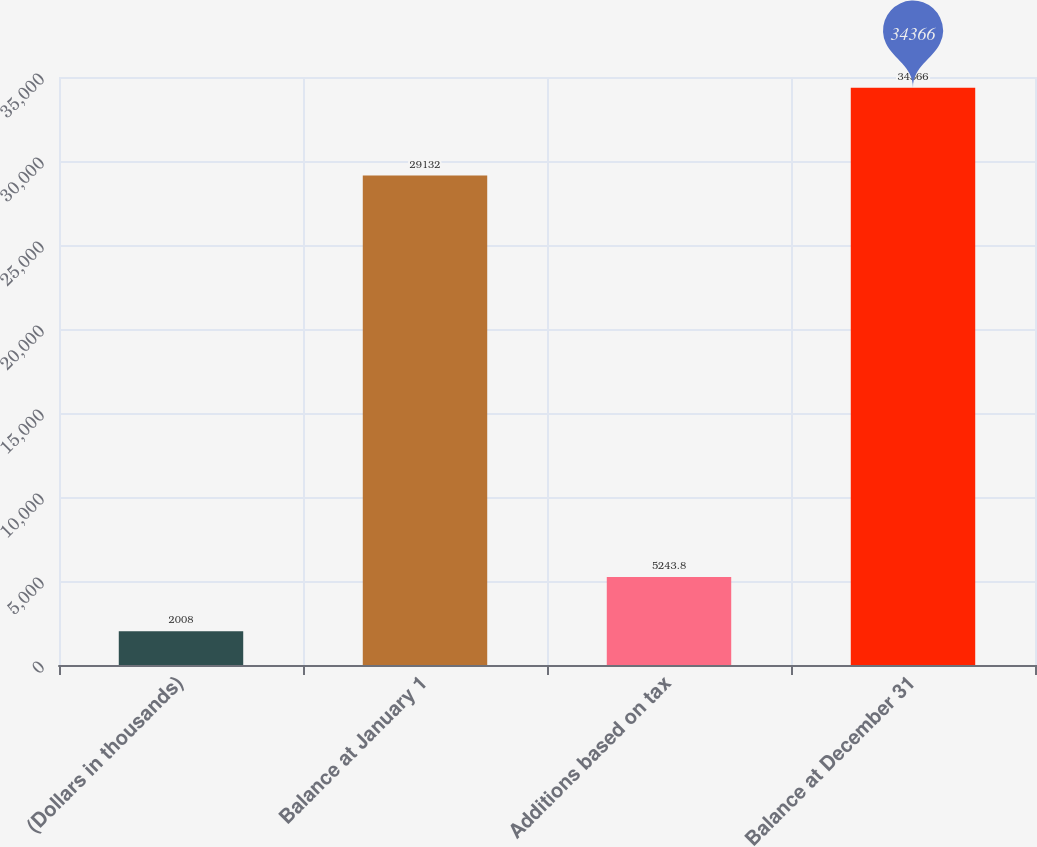Convert chart. <chart><loc_0><loc_0><loc_500><loc_500><bar_chart><fcel>(Dollars in thousands)<fcel>Balance at January 1<fcel>Additions based on tax<fcel>Balance at December 31<nl><fcel>2008<fcel>29132<fcel>5243.8<fcel>34366<nl></chart> 